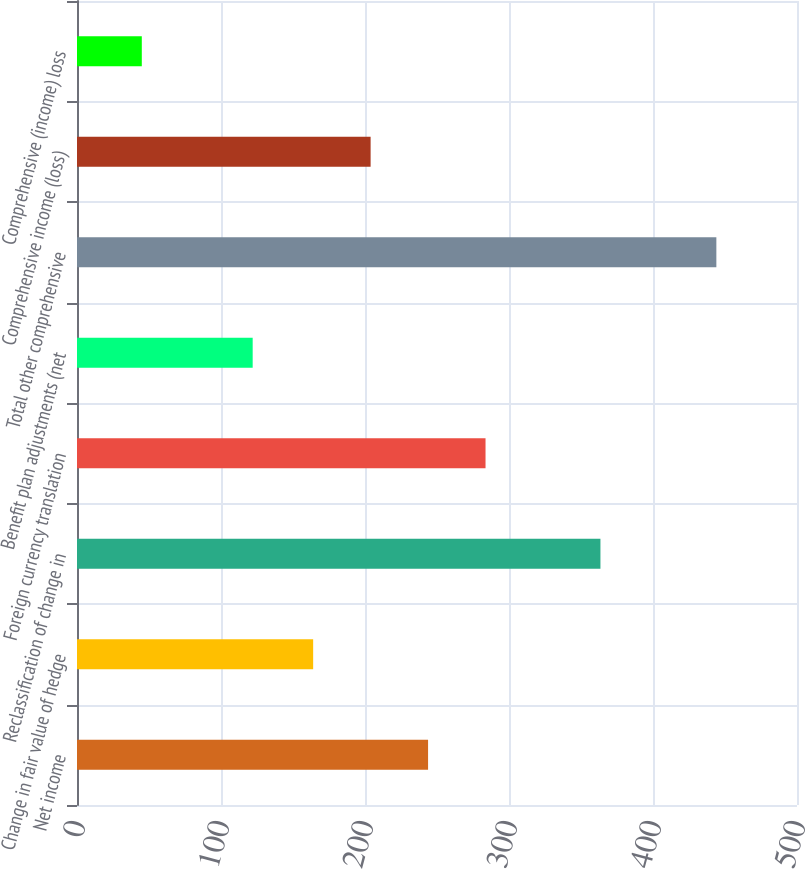Convert chart to OTSL. <chart><loc_0><loc_0><loc_500><loc_500><bar_chart><fcel>Net income<fcel>Change in fair value of hedge<fcel>Reclassification of change in<fcel>Foreign currency translation<fcel>Benefit plan adjustments (net<fcel>Total other comprehensive<fcel>Comprehensive income (loss)<fcel>Comprehensive (income) loss<nl><fcel>243.8<fcel>164<fcel>363.5<fcel>283.7<fcel>122<fcel>444<fcel>203.9<fcel>45<nl></chart> 